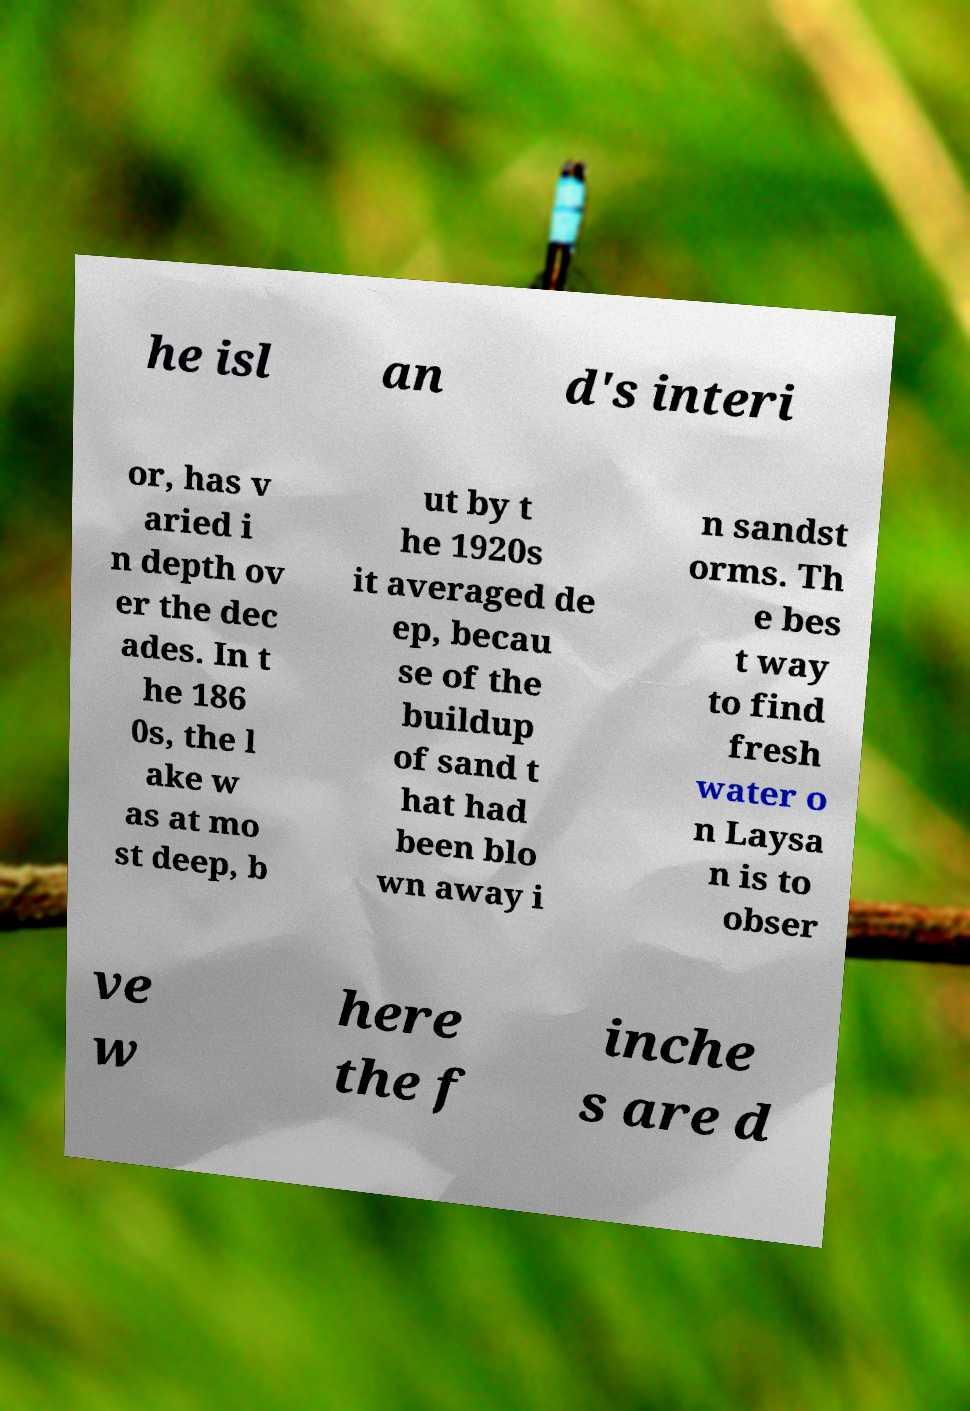There's text embedded in this image that I need extracted. Can you transcribe it verbatim? he isl an d's interi or, has v aried i n depth ov er the dec ades. In t he 186 0s, the l ake w as at mo st deep, b ut by t he 1920s it averaged de ep, becau se of the buildup of sand t hat had been blo wn away i n sandst orms. Th e bes t way to find fresh water o n Laysa n is to obser ve w here the f inche s are d 